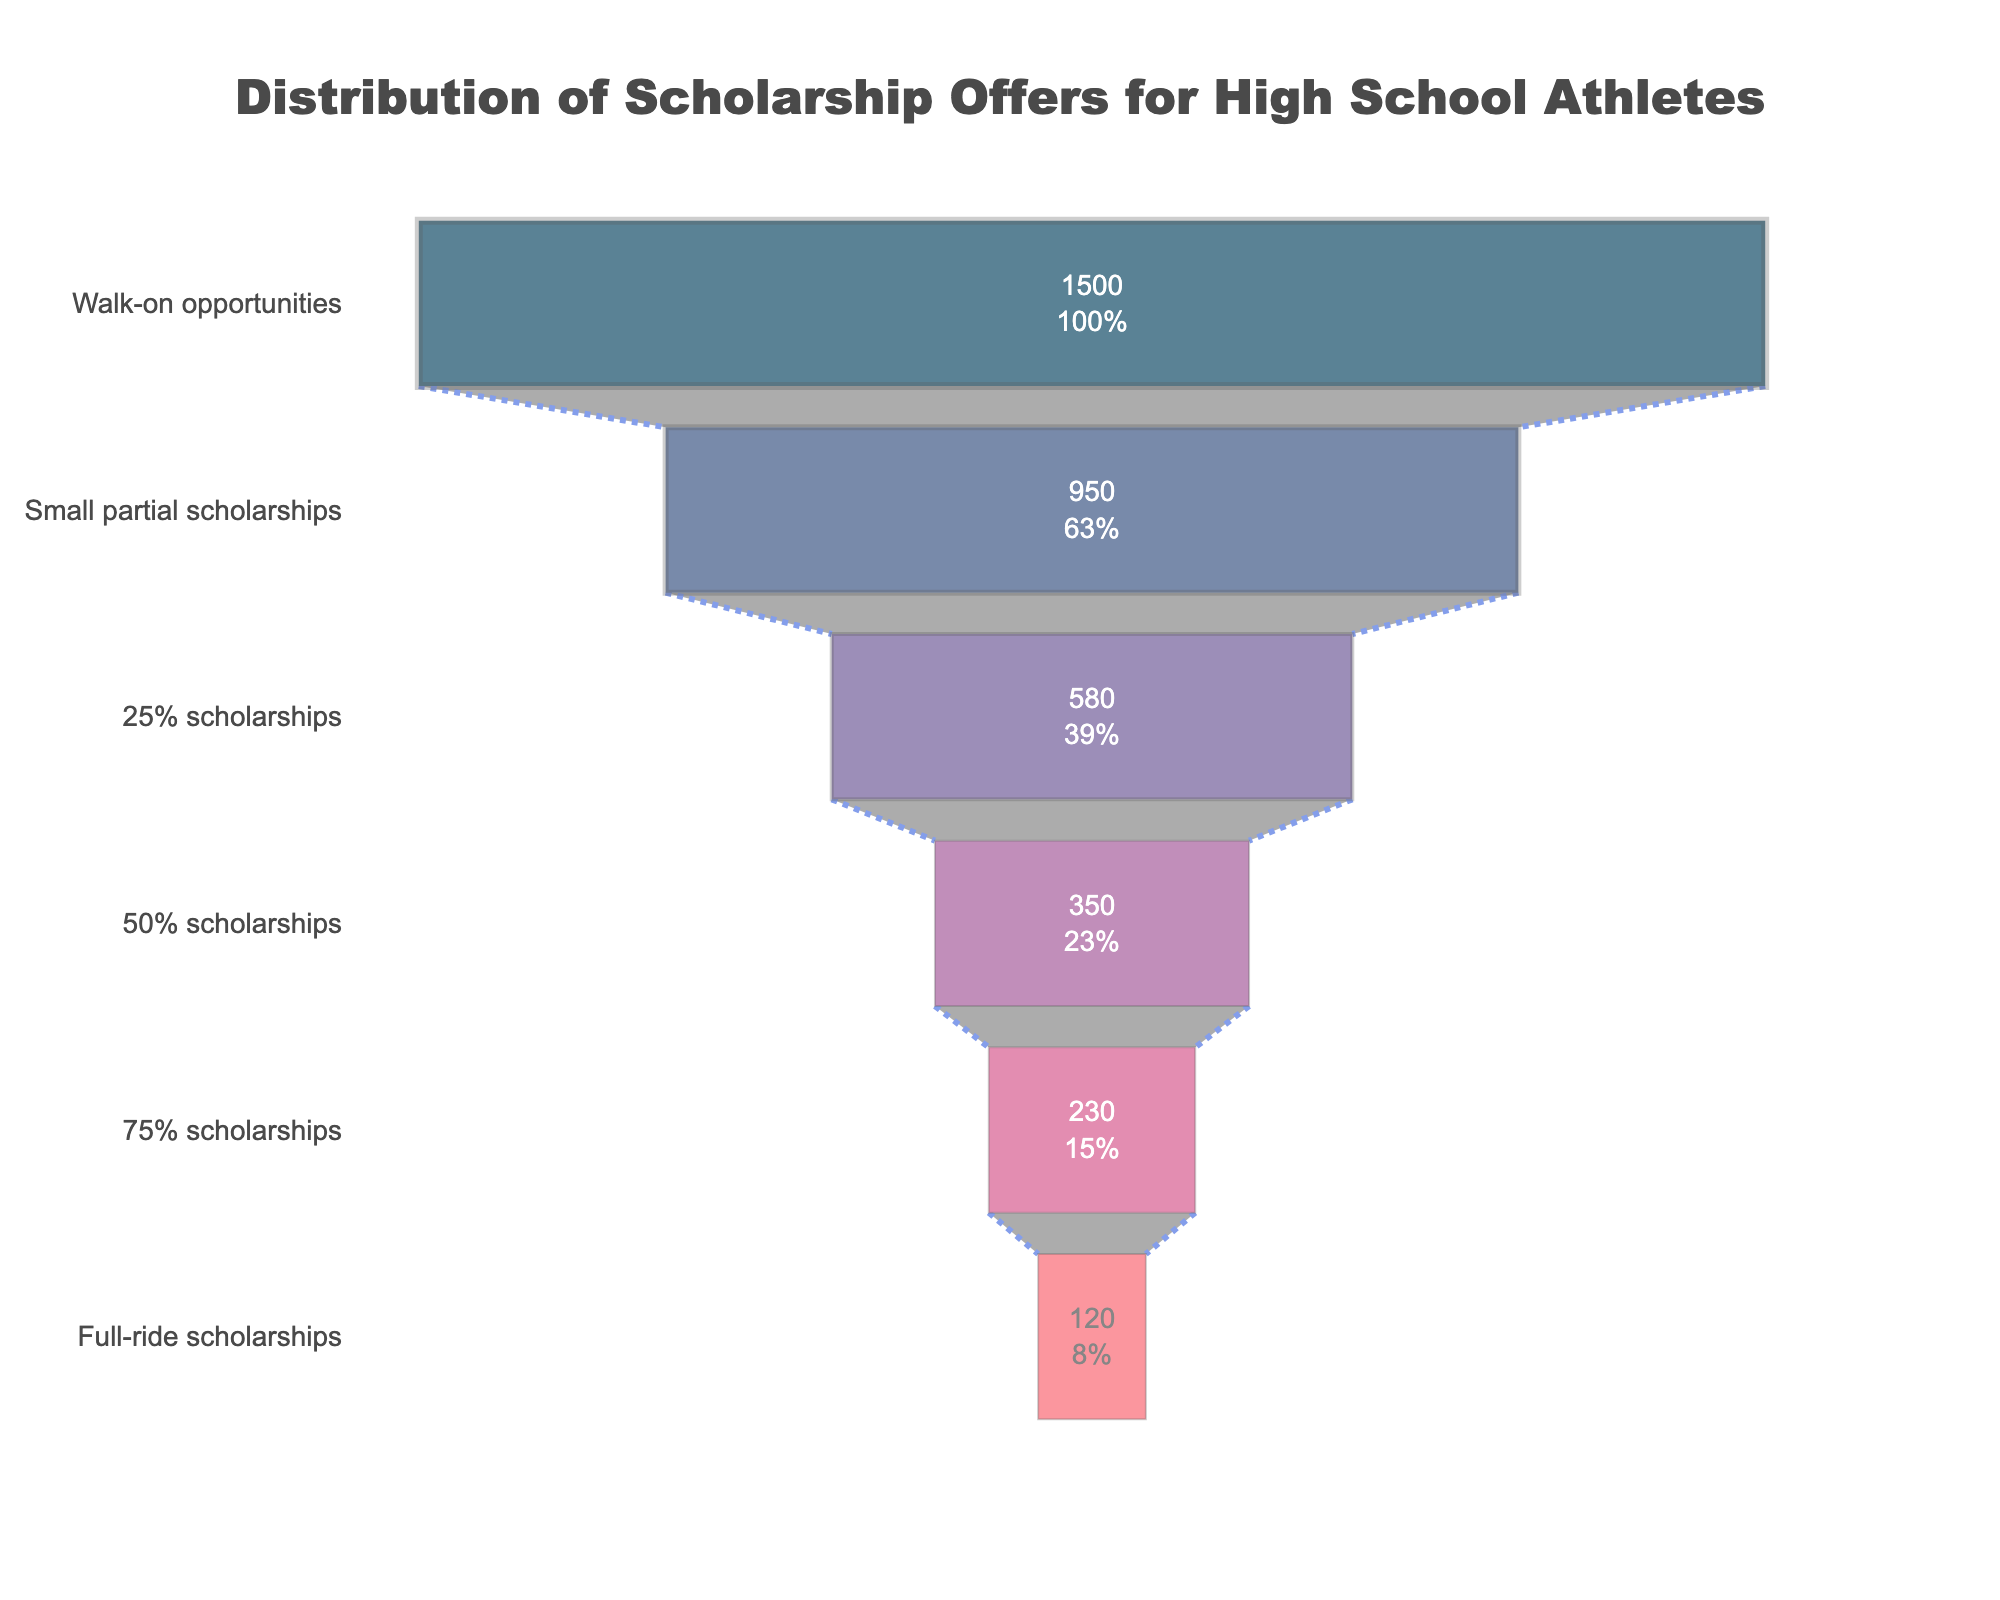How many scholarship types are represented in the figure? Count the number of different scholarship categories displayed on the Y-axis. There are six different scholarship types: Full-ride scholarships, 75% scholarships, 50% scholarships, 25% scholarships, Small partial scholarships, Walk-on opportunities
Answer: Six Which scholarship type has the highest number of athletes? Identify the category with the largest bar on the X-axis. The Walk-on opportunities category has the highest number of athletes at 1500
Answer: Walk-on opportunities What is the total number of athletes receiving some form of scholarship (excluding walk-on opportunities)? Sum the number of athletes for the categories: Full-ride scholarships, 75% scholarships, 50% scholarships, 25% scholarships, and Small partial scholarships. (120 + 230 + 350 + 580 + 950) = 2,230
Answer: 2,230 What percentage of the total athletes receive full-ride scholarships? Calculate the percentage of full-ride scholarships out of the total athletes: (120/4800) * 100 = 2.5%. Total athletes include all categories (120 + 230 + 350 + 580 + 950 + 1500 = 3,730)
Answer: 2.5% How does the number of athletes with 50% scholarships compare to those with full-ride scholarships? Subtract the number of athletes with full-ride scholarships from those with 50% scholarships: 350 - 120 = 230. Therefore, the 50% scholarship category has 230 more athletes than the full-ride scholarship category
Answer: 230 more Which scholarship type has the second smallest number of athletes? Identify the second smallest bar on the X-axis. The 75% scholarships category, with 230 athletes, is the second smallest after Full-ride scholarships
Answer: 75% scholarships What is the average number of athletes across all scholarship types? Sum the number of athletes in all categories and divide by the number of categories: (120 + 230 + 350 + 580 + 950 + 1500)/6 = 3,730/6 ≈ 621.67
Answer: Approximately 622 What proportion of athletes receive 25% scholarships compared to small partial scholarships? Divide the number of athletes receiving 25% scholarships by those receiving small partial scholarships and multiply by 100 to get the percentage: (580 / 950) * 100 ≈ 61.05%
Answer: Approximately 61% If the number of athletes receiving walk-on opportunities increased by 10%, what would the new total number be? Calculate 10% of the walk-on opportunities (1500 * 0.10) = 150; then add to the original number: 1500 + 150 = 1650
Answer: 1,650 What is the difference in the number of athletes between 25% scholarships and 75% scholarships? Subtract the number of athletes with 75% scholarships from those with 25% scholarships: 580 - 230 = 350
Answer: 350 